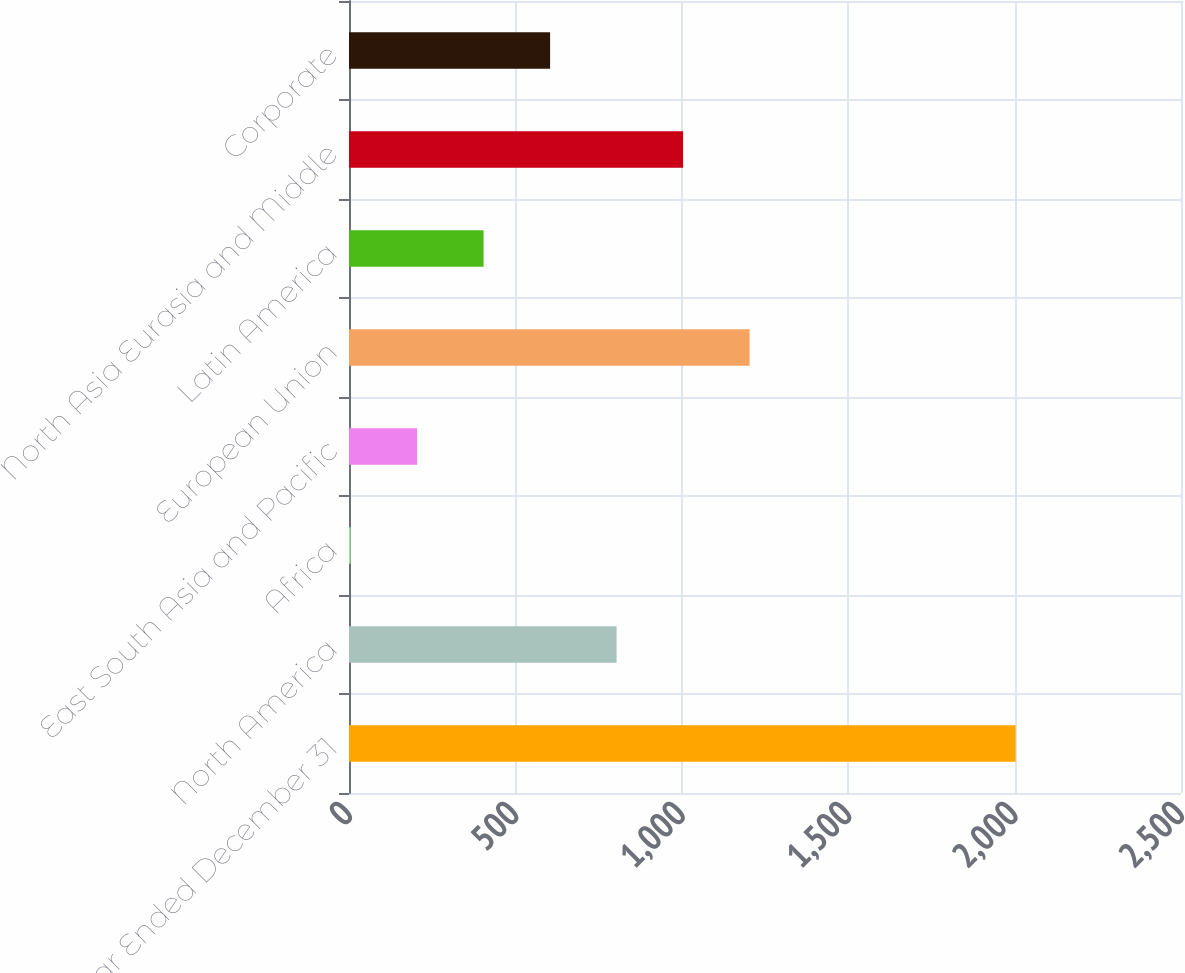<chart> <loc_0><loc_0><loc_500><loc_500><bar_chart><fcel>Year Ended December 31<fcel>North America<fcel>Africa<fcel>East South Asia and Pacific<fcel>European Union<fcel>Latin America<fcel>North Asia Eurasia and Middle<fcel>Corporate<nl><fcel>2003<fcel>804.08<fcel>4.8<fcel>204.62<fcel>1203.72<fcel>404.44<fcel>1003.9<fcel>604.26<nl></chart> 